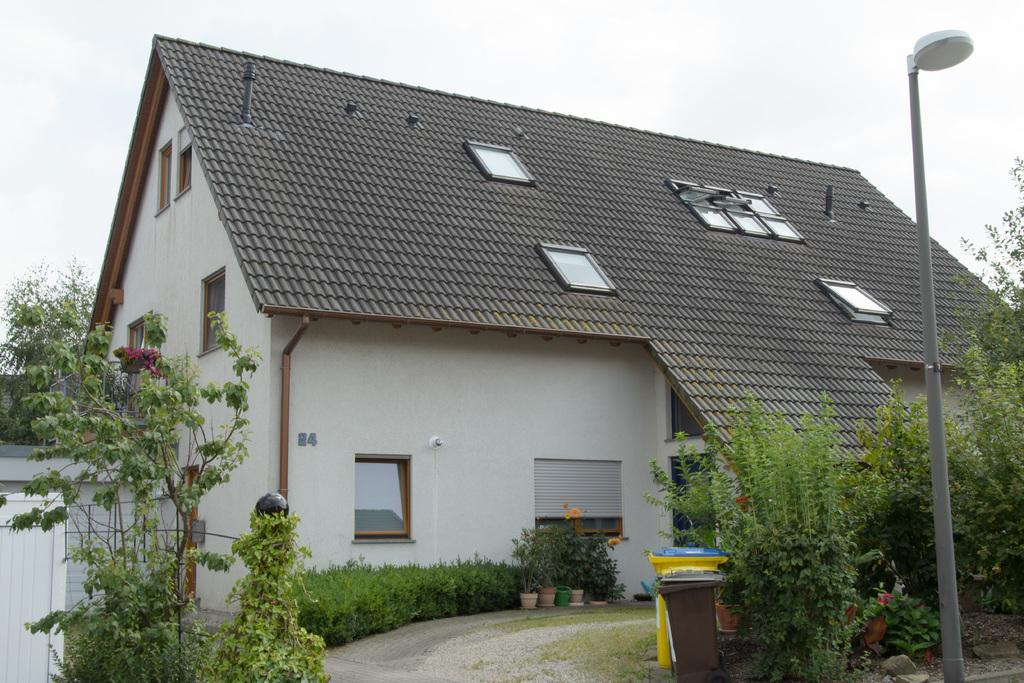What type of structure is visible in the image? There is a house in the image. What features can be seen on the house? The house has windows. What type of vegetation is present in the image? There are plants and trees in the image. What is the purpose of the pole in the image? The pole has a lamp on it. What type of advice can be seen written on the house in the image? There is no advice written on the house in the image. What type of glove is being used to water the plants in the image? There is no glove present in the image, and the plants are not being watered. 